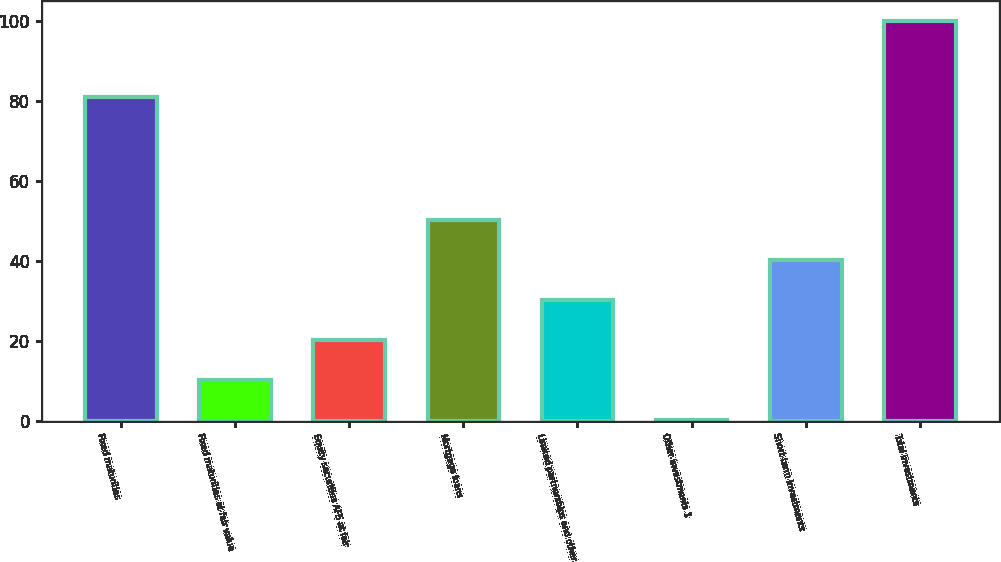Convert chart to OTSL. <chart><loc_0><loc_0><loc_500><loc_500><bar_chart><fcel>Fixed maturities<fcel>Fixed maturities at fair value<fcel>Equity securities AFS at fair<fcel>Mortgage loans<fcel>Limited partnerships and other<fcel>Other investments 1<fcel>Short-term investments<fcel>Total investments<nl><fcel>80.9<fcel>10.27<fcel>20.24<fcel>50.15<fcel>30.21<fcel>0.3<fcel>40.18<fcel>100<nl></chart> 